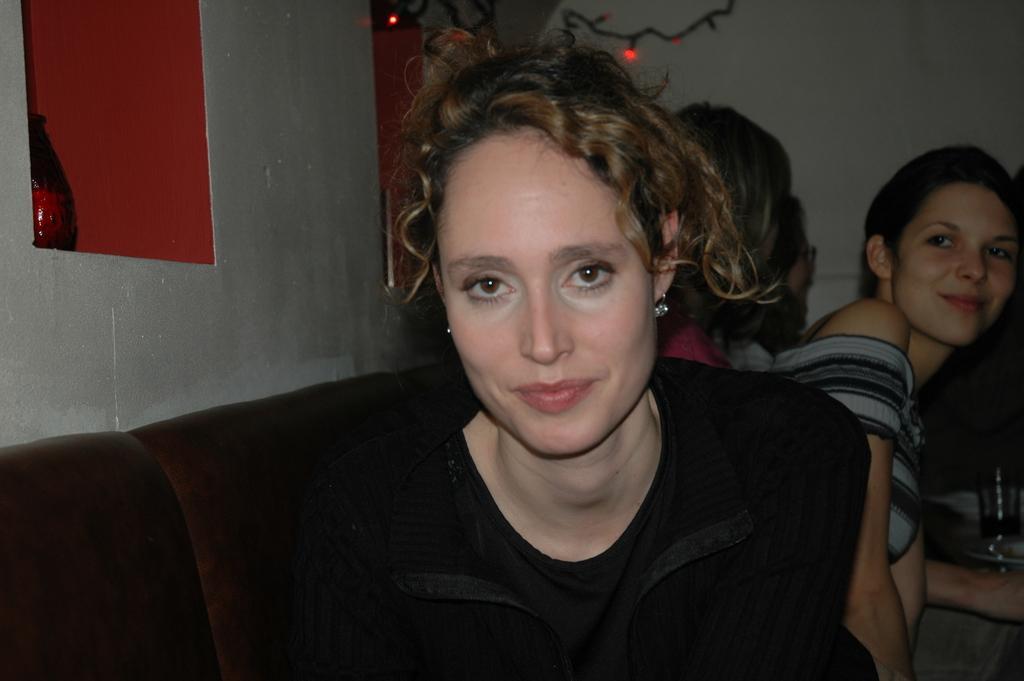How would you summarize this image in a sentence or two? In the center of the image we can see one woman is sitting on the couch. And she is smiling, which we can see on her face. And she is in black color top. In the background there is a wall, string lights, decorative items, one table, one glass, few people are sitting and a few other objects. Among them, we can see one woman is smiling. 